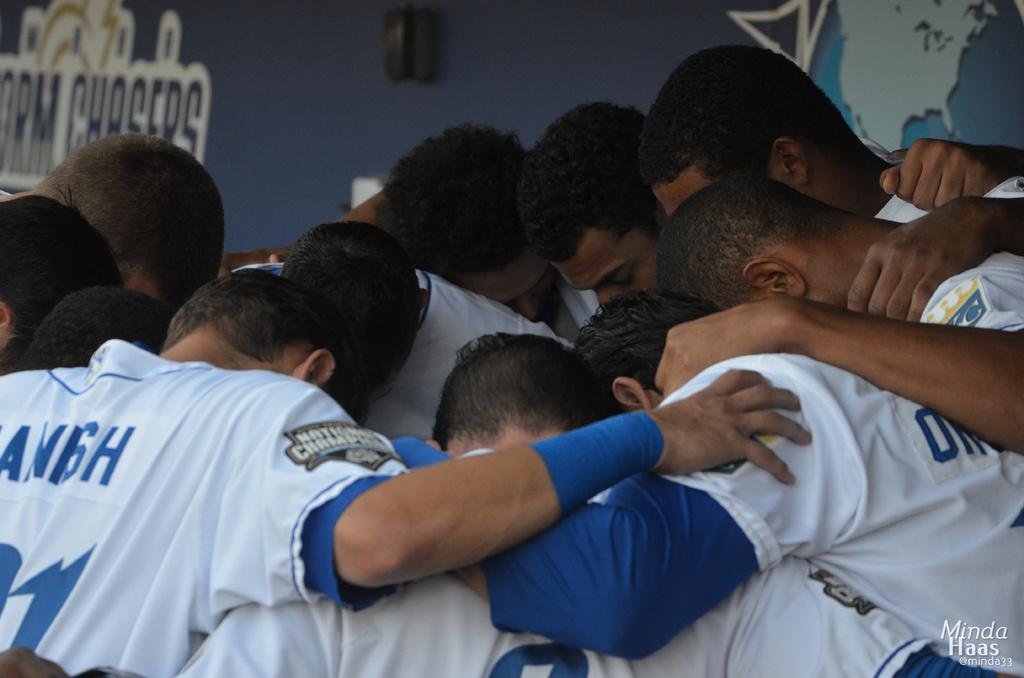What is the main subject in the foreground of the image? There is a group of people in the foreground of the image. What can be seen in the background of the image? There is a well in the background of the image. What is present on the wall in the image? There are posters on the wall. What type of drain is visible in the image? There is no drain present in the image. What type of trade is being conducted by the group of people in the image? The image does not provide information about any trade being conducted by the group of people. 